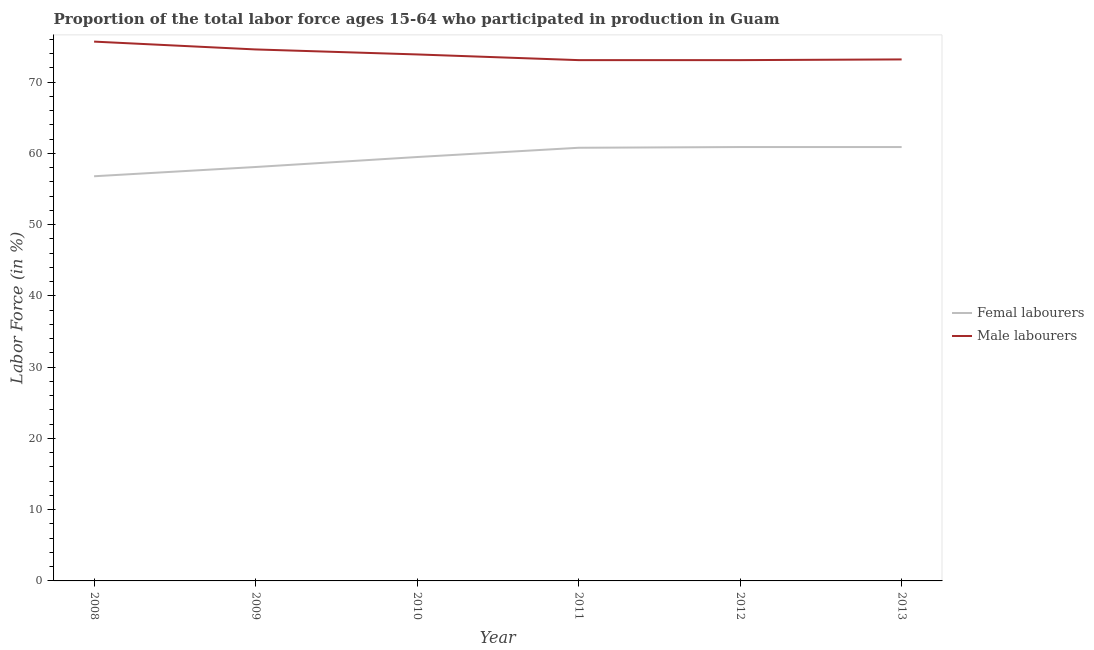How many different coloured lines are there?
Your response must be concise. 2. Is the number of lines equal to the number of legend labels?
Provide a short and direct response. Yes. What is the percentage of female labor force in 2008?
Give a very brief answer. 56.8. Across all years, what is the maximum percentage of male labour force?
Your response must be concise. 75.7. Across all years, what is the minimum percentage of male labour force?
Provide a succinct answer. 73.1. In which year was the percentage of female labor force minimum?
Ensure brevity in your answer.  2008. What is the total percentage of female labor force in the graph?
Offer a terse response. 357. What is the difference between the percentage of female labor force in 2008 and the percentage of male labour force in 2012?
Your response must be concise. -16.3. What is the average percentage of male labour force per year?
Give a very brief answer. 73.93. In the year 2010, what is the difference between the percentage of female labor force and percentage of male labour force?
Your answer should be very brief. -14.4. What is the ratio of the percentage of female labor force in 2010 to that in 2013?
Keep it short and to the point. 0.98. Is the difference between the percentage of female labor force in 2010 and 2012 greater than the difference between the percentage of male labour force in 2010 and 2012?
Keep it short and to the point. No. What is the difference between the highest and the second highest percentage of male labour force?
Your response must be concise. 1.1. What is the difference between the highest and the lowest percentage of female labor force?
Provide a short and direct response. 4.1. Is the sum of the percentage of male labour force in 2008 and 2012 greater than the maximum percentage of female labor force across all years?
Provide a succinct answer. Yes. Does the percentage of female labor force monotonically increase over the years?
Provide a short and direct response. No. Is the percentage of female labor force strictly greater than the percentage of male labour force over the years?
Make the answer very short. No. Is the percentage of female labor force strictly less than the percentage of male labour force over the years?
Keep it short and to the point. Yes. How many lines are there?
Give a very brief answer. 2. How many years are there in the graph?
Your response must be concise. 6. What is the difference between two consecutive major ticks on the Y-axis?
Give a very brief answer. 10. Are the values on the major ticks of Y-axis written in scientific E-notation?
Your response must be concise. No. Does the graph contain grids?
Provide a short and direct response. No. How are the legend labels stacked?
Ensure brevity in your answer.  Vertical. What is the title of the graph?
Keep it short and to the point. Proportion of the total labor force ages 15-64 who participated in production in Guam. What is the label or title of the X-axis?
Offer a terse response. Year. What is the label or title of the Y-axis?
Offer a very short reply. Labor Force (in %). What is the Labor Force (in %) of Femal labourers in 2008?
Make the answer very short. 56.8. What is the Labor Force (in %) of Male labourers in 2008?
Ensure brevity in your answer.  75.7. What is the Labor Force (in %) in Femal labourers in 2009?
Offer a very short reply. 58.1. What is the Labor Force (in %) of Male labourers in 2009?
Provide a short and direct response. 74.6. What is the Labor Force (in %) of Femal labourers in 2010?
Your response must be concise. 59.5. What is the Labor Force (in %) in Male labourers in 2010?
Your answer should be very brief. 73.9. What is the Labor Force (in %) in Femal labourers in 2011?
Ensure brevity in your answer.  60.8. What is the Labor Force (in %) of Male labourers in 2011?
Your answer should be very brief. 73.1. What is the Labor Force (in %) of Femal labourers in 2012?
Ensure brevity in your answer.  60.9. What is the Labor Force (in %) in Male labourers in 2012?
Give a very brief answer. 73.1. What is the Labor Force (in %) of Femal labourers in 2013?
Offer a terse response. 60.9. What is the Labor Force (in %) of Male labourers in 2013?
Your response must be concise. 73.2. Across all years, what is the maximum Labor Force (in %) in Femal labourers?
Keep it short and to the point. 60.9. Across all years, what is the maximum Labor Force (in %) in Male labourers?
Give a very brief answer. 75.7. Across all years, what is the minimum Labor Force (in %) in Femal labourers?
Give a very brief answer. 56.8. Across all years, what is the minimum Labor Force (in %) of Male labourers?
Your answer should be compact. 73.1. What is the total Labor Force (in %) of Femal labourers in the graph?
Ensure brevity in your answer.  357. What is the total Labor Force (in %) of Male labourers in the graph?
Keep it short and to the point. 443.6. What is the difference between the Labor Force (in %) of Male labourers in 2008 and that in 2009?
Offer a terse response. 1.1. What is the difference between the Labor Force (in %) of Femal labourers in 2008 and that in 2010?
Your response must be concise. -2.7. What is the difference between the Labor Force (in %) in Male labourers in 2008 and that in 2011?
Your answer should be very brief. 2.6. What is the difference between the Labor Force (in %) of Male labourers in 2008 and that in 2013?
Offer a terse response. 2.5. What is the difference between the Labor Force (in %) in Femal labourers in 2009 and that in 2010?
Offer a terse response. -1.4. What is the difference between the Labor Force (in %) in Male labourers in 2009 and that in 2010?
Your answer should be very brief. 0.7. What is the difference between the Labor Force (in %) of Femal labourers in 2009 and that in 2012?
Your answer should be compact. -2.8. What is the difference between the Labor Force (in %) in Male labourers in 2009 and that in 2013?
Offer a terse response. 1.4. What is the difference between the Labor Force (in %) in Femal labourers in 2010 and that in 2011?
Offer a very short reply. -1.3. What is the difference between the Labor Force (in %) of Male labourers in 2010 and that in 2011?
Ensure brevity in your answer.  0.8. What is the difference between the Labor Force (in %) in Femal labourers in 2010 and that in 2013?
Your answer should be very brief. -1.4. What is the difference between the Labor Force (in %) of Male labourers in 2011 and that in 2012?
Make the answer very short. 0. What is the difference between the Labor Force (in %) in Femal labourers in 2011 and that in 2013?
Provide a succinct answer. -0.1. What is the difference between the Labor Force (in %) of Male labourers in 2011 and that in 2013?
Provide a succinct answer. -0.1. What is the difference between the Labor Force (in %) of Male labourers in 2012 and that in 2013?
Ensure brevity in your answer.  -0.1. What is the difference between the Labor Force (in %) in Femal labourers in 2008 and the Labor Force (in %) in Male labourers in 2009?
Offer a very short reply. -17.8. What is the difference between the Labor Force (in %) in Femal labourers in 2008 and the Labor Force (in %) in Male labourers in 2010?
Offer a very short reply. -17.1. What is the difference between the Labor Force (in %) of Femal labourers in 2008 and the Labor Force (in %) of Male labourers in 2011?
Give a very brief answer. -16.3. What is the difference between the Labor Force (in %) of Femal labourers in 2008 and the Labor Force (in %) of Male labourers in 2012?
Your answer should be very brief. -16.3. What is the difference between the Labor Force (in %) of Femal labourers in 2008 and the Labor Force (in %) of Male labourers in 2013?
Your answer should be compact. -16.4. What is the difference between the Labor Force (in %) of Femal labourers in 2009 and the Labor Force (in %) of Male labourers in 2010?
Give a very brief answer. -15.8. What is the difference between the Labor Force (in %) of Femal labourers in 2009 and the Labor Force (in %) of Male labourers in 2011?
Offer a very short reply. -15. What is the difference between the Labor Force (in %) in Femal labourers in 2009 and the Labor Force (in %) in Male labourers in 2012?
Provide a short and direct response. -15. What is the difference between the Labor Force (in %) of Femal labourers in 2009 and the Labor Force (in %) of Male labourers in 2013?
Provide a short and direct response. -15.1. What is the difference between the Labor Force (in %) in Femal labourers in 2010 and the Labor Force (in %) in Male labourers in 2011?
Your response must be concise. -13.6. What is the difference between the Labor Force (in %) of Femal labourers in 2010 and the Labor Force (in %) of Male labourers in 2012?
Make the answer very short. -13.6. What is the difference between the Labor Force (in %) of Femal labourers in 2010 and the Labor Force (in %) of Male labourers in 2013?
Your answer should be compact. -13.7. What is the difference between the Labor Force (in %) in Femal labourers in 2011 and the Labor Force (in %) in Male labourers in 2012?
Make the answer very short. -12.3. What is the difference between the Labor Force (in %) of Femal labourers in 2011 and the Labor Force (in %) of Male labourers in 2013?
Give a very brief answer. -12.4. What is the difference between the Labor Force (in %) in Femal labourers in 2012 and the Labor Force (in %) in Male labourers in 2013?
Your answer should be compact. -12.3. What is the average Labor Force (in %) in Femal labourers per year?
Provide a short and direct response. 59.5. What is the average Labor Force (in %) in Male labourers per year?
Give a very brief answer. 73.93. In the year 2008, what is the difference between the Labor Force (in %) in Femal labourers and Labor Force (in %) in Male labourers?
Offer a very short reply. -18.9. In the year 2009, what is the difference between the Labor Force (in %) of Femal labourers and Labor Force (in %) of Male labourers?
Keep it short and to the point. -16.5. In the year 2010, what is the difference between the Labor Force (in %) in Femal labourers and Labor Force (in %) in Male labourers?
Your answer should be very brief. -14.4. In the year 2011, what is the difference between the Labor Force (in %) in Femal labourers and Labor Force (in %) in Male labourers?
Offer a terse response. -12.3. What is the ratio of the Labor Force (in %) in Femal labourers in 2008 to that in 2009?
Ensure brevity in your answer.  0.98. What is the ratio of the Labor Force (in %) of Male labourers in 2008 to that in 2009?
Your response must be concise. 1.01. What is the ratio of the Labor Force (in %) in Femal labourers in 2008 to that in 2010?
Your response must be concise. 0.95. What is the ratio of the Labor Force (in %) in Male labourers in 2008 to that in 2010?
Make the answer very short. 1.02. What is the ratio of the Labor Force (in %) of Femal labourers in 2008 to that in 2011?
Provide a short and direct response. 0.93. What is the ratio of the Labor Force (in %) in Male labourers in 2008 to that in 2011?
Your answer should be compact. 1.04. What is the ratio of the Labor Force (in %) in Femal labourers in 2008 to that in 2012?
Provide a short and direct response. 0.93. What is the ratio of the Labor Force (in %) of Male labourers in 2008 to that in 2012?
Your answer should be very brief. 1.04. What is the ratio of the Labor Force (in %) of Femal labourers in 2008 to that in 2013?
Your answer should be compact. 0.93. What is the ratio of the Labor Force (in %) in Male labourers in 2008 to that in 2013?
Ensure brevity in your answer.  1.03. What is the ratio of the Labor Force (in %) in Femal labourers in 2009 to that in 2010?
Your answer should be very brief. 0.98. What is the ratio of the Labor Force (in %) of Male labourers in 2009 to that in 2010?
Make the answer very short. 1.01. What is the ratio of the Labor Force (in %) in Femal labourers in 2009 to that in 2011?
Your answer should be compact. 0.96. What is the ratio of the Labor Force (in %) of Male labourers in 2009 to that in 2011?
Provide a short and direct response. 1.02. What is the ratio of the Labor Force (in %) of Femal labourers in 2009 to that in 2012?
Provide a succinct answer. 0.95. What is the ratio of the Labor Force (in %) in Male labourers in 2009 to that in 2012?
Give a very brief answer. 1.02. What is the ratio of the Labor Force (in %) of Femal labourers in 2009 to that in 2013?
Ensure brevity in your answer.  0.95. What is the ratio of the Labor Force (in %) of Male labourers in 2009 to that in 2013?
Keep it short and to the point. 1.02. What is the ratio of the Labor Force (in %) in Femal labourers in 2010 to that in 2011?
Keep it short and to the point. 0.98. What is the ratio of the Labor Force (in %) of Male labourers in 2010 to that in 2011?
Your answer should be compact. 1.01. What is the ratio of the Labor Force (in %) in Femal labourers in 2010 to that in 2012?
Your response must be concise. 0.98. What is the ratio of the Labor Force (in %) in Male labourers in 2010 to that in 2012?
Keep it short and to the point. 1.01. What is the ratio of the Labor Force (in %) in Male labourers in 2010 to that in 2013?
Your answer should be very brief. 1.01. What is the ratio of the Labor Force (in %) of Femal labourers in 2011 to that in 2012?
Offer a terse response. 1. What is the ratio of the Labor Force (in %) in Male labourers in 2011 to that in 2012?
Your answer should be very brief. 1. What is the ratio of the Labor Force (in %) of Femal labourers in 2012 to that in 2013?
Your answer should be very brief. 1. What is the ratio of the Labor Force (in %) in Male labourers in 2012 to that in 2013?
Give a very brief answer. 1. What is the difference between the highest and the second highest Labor Force (in %) of Femal labourers?
Offer a terse response. 0. What is the difference between the highest and the lowest Labor Force (in %) in Femal labourers?
Your answer should be very brief. 4.1. What is the difference between the highest and the lowest Labor Force (in %) in Male labourers?
Your answer should be compact. 2.6. 